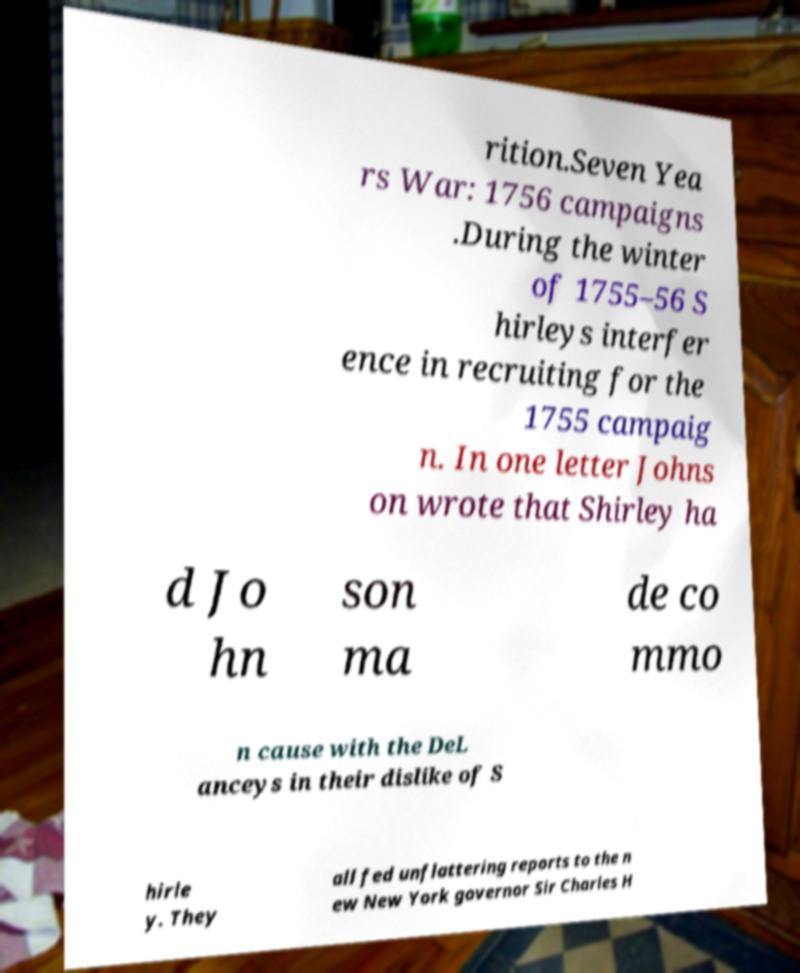Can you accurately transcribe the text from the provided image for me? rition.Seven Yea rs War: 1756 campaigns .During the winter of 1755–56 S hirleys interfer ence in recruiting for the 1755 campaig n. In one letter Johns on wrote that Shirley ha d Jo hn son ma de co mmo n cause with the DeL anceys in their dislike of S hirle y. They all fed unflattering reports to the n ew New York governor Sir Charles H 